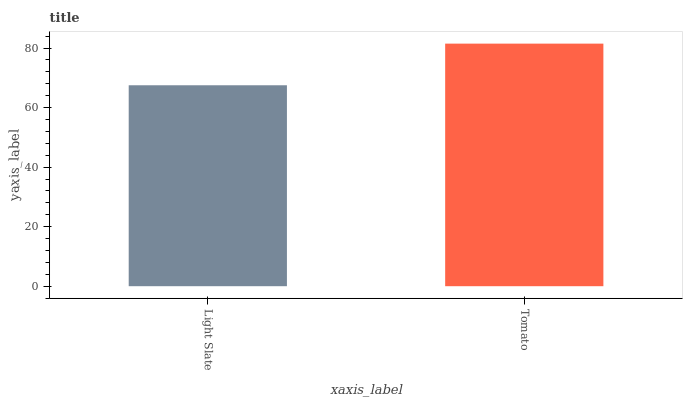Is Light Slate the minimum?
Answer yes or no. Yes. Is Tomato the maximum?
Answer yes or no. Yes. Is Tomato the minimum?
Answer yes or no. No. Is Tomato greater than Light Slate?
Answer yes or no. Yes. Is Light Slate less than Tomato?
Answer yes or no. Yes. Is Light Slate greater than Tomato?
Answer yes or no. No. Is Tomato less than Light Slate?
Answer yes or no. No. Is Tomato the high median?
Answer yes or no. Yes. Is Light Slate the low median?
Answer yes or no. Yes. Is Light Slate the high median?
Answer yes or no. No. Is Tomato the low median?
Answer yes or no. No. 